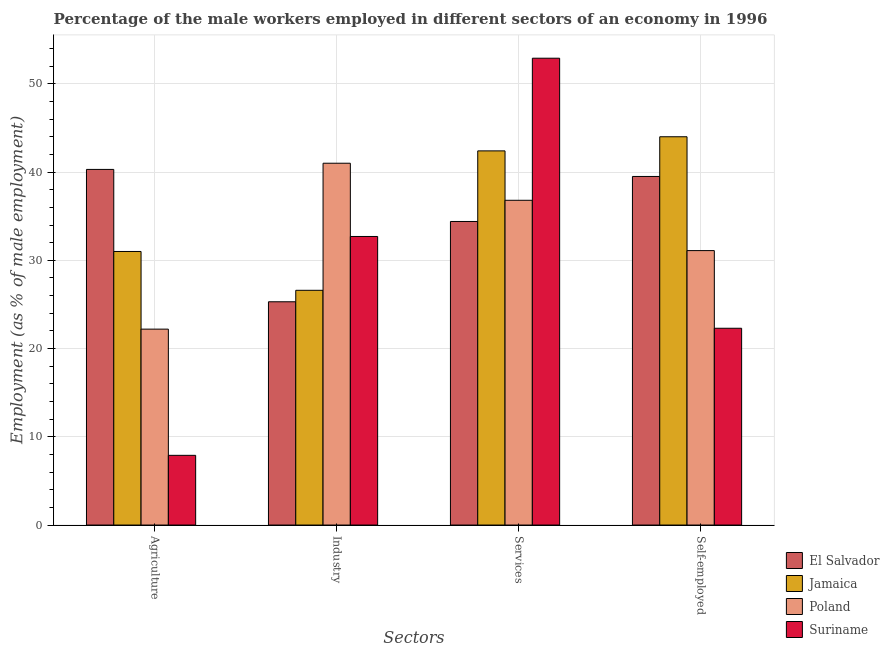How many different coloured bars are there?
Keep it short and to the point. 4. How many bars are there on the 4th tick from the right?
Offer a terse response. 4. What is the label of the 1st group of bars from the left?
Provide a short and direct response. Agriculture. What is the percentage of self employed male workers in Suriname?
Your response must be concise. 22.3. Across all countries, what is the maximum percentage of male workers in services?
Offer a very short reply. 52.9. Across all countries, what is the minimum percentage of self employed male workers?
Keep it short and to the point. 22.3. In which country was the percentage of male workers in agriculture maximum?
Offer a very short reply. El Salvador. In which country was the percentage of male workers in industry minimum?
Ensure brevity in your answer.  El Salvador. What is the total percentage of male workers in services in the graph?
Offer a terse response. 166.5. What is the difference between the percentage of male workers in agriculture in Poland and that in El Salvador?
Provide a short and direct response. -18.1. What is the difference between the percentage of male workers in industry in Suriname and the percentage of male workers in services in Poland?
Keep it short and to the point. -4.1. What is the average percentage of male workers in services per country?
Provide a succinct answer. 41.63. What is the difference between the percentage of self employed male workers and percentage of male workers in agriculture in El Salvador?
Provide a succinct answer. -0.8. In how many countries, is the percentage of male workers in services greater than 48 %?
Your answer should be compact. 1. What is the ratio of the percentage of male workers in services in Jamaica to that in El Salvador?
Offer a very short reply. 1.23. What is the difference between the highest and the second highest percentage of self employed male workers?
Your response must be concise. 4.5. What is the difference between the highest and the lowest percentage of male workers in agriculture?
Provide a short and direct response. 32.4. Is the sum of the percentage of male workers in industry in Jamaica and Suriname greater than the maximum percentage of male workers in services across all countries?
Offer a terse response. Yes. Is it the case that in every country, the sum of the percentage of male workers in agriculture and percentage of male workers in industry is greater than the sum of percentage of male workers in services and percentage of self employed male workers?
Your answer should be very brief. No. What does the 2nd bar from the left in Industry represents?
Your answer should be compact. Jamaica. What does the 4th bar from the right in Services represents?
Your answer should be compact. El Salvador. Is it the case that in every country, the sum of the percentage of male workers in agriculture and percentage of male workers in industry is greater than the percentage of male workers in services?
Offer a very short reply. No. How many bars are there?
Give a very brief answer. 16. Are all the bars in the graph horizontal?
Offer a terse response. No. How many countries are there in the graph?
Your answer should be very brief. 4. Are the values on the major ticks of Y-axis written in scientific E-notation?
Provide a succinct answer. No. Does the graph contain any zero values?
Offer a terse response. No. Does the graph contain grids?
Ensure brevity in your answer.  Yes. How many legend labels are there?
Provide a short and direct response. 4. How are the legend labels stacked?
Offer a very short reply. Vertical. What is the title of the graph?
Your answer should be very brief. Percentage of the male workers employed in different sectors of an economy in 1996. What is the label or title of the X-axis?
Keep it short and to the point. Sectors. What is the label or title of the Y-axis?
Offer a terse response. Employment (as % of male employment). What is the Employment (as % of male employment) in El Salvador in Agriculture?
Give a very brief answer. 40.3. What is the Employment (as % of male employment) of Poland in Agriculture?
Ensure brevity in your answer.  22.2. What is the Employment (as % of male employment) of Suriname in Agriculture?
Give a very brief answer. 7.9. What is the Employment (as % of male employment) in El Salvador in Industry?
Give a very brief answer. 25.3. What is the Employment (as % of male employment) of Jamaica in Industry?
Give a very brief answer. 26.6. What is the Employment (as % of male employment) in Suriname in Industry?
Give a very brief answer. 32.7. What is the Employment (as % of male employment) in El Salvador in Services?
Give a very brief answer. 34.4. What is the Employment (as % of male employment) of Jamaica in Services?
Ensure brevity in your answer.  42.4. What is the Employment (as % of male employment) of Poland in Services?
Your answer should be very brief. 36.8. What is the Employment (as % of male employment) of Suriname in Services?
Provide a short and direct response. 52.9. What is the Employment (as % of male employment) in El Salvador in Self-employed?
Your answer should be very brief. 39.5. What is the Employment (as % of male employment) of Poland in Self-employed?
Keep it short and to the point. 31.1. What is the Employment (as % of male employment) in Suriname in Self-employed?
Offer a terse response. 22.3. Across all Sectors, what is the maximum Employment (as % of male employment) in El Salvador?
Ensure brevity in your answer.  40.3. Across all Sectors, what is the maximum Employment (as % of male employment) in Poland?
Your response must be concise. 41. Across all Sectors, what is the maximum Employment (as % of male employment) in Suriname?
Keep it short and to the point. 52.9. Across all Sectors, what is the minimum Employment (as % of male employment) in El Salvador?
Provide a succinct answer. 25.3. Across all Sectors, what is the minimum Employment (as % of male employment) in Jamaica?
Offer a very short reply. 26.6. Across all Sectors, what is the minimum Employment (as % of male employment) of Poland?
Provide a short and direct response. 22.2. Across all Sectors, what is the minimum Employment (as % of male employment) of Suriname?
Provide a short and direct response. 7.9. What is the total Employment (as % of male employment) of El Salvador in the graph?
Your answer should be compact. 139.5. What is the total Employment (as % of male employment) in Jamaica in the graph?
Give a very brief answer. 144. What is the total Employment (as % of male employment) in Poland in the graph?
Your response must be concise. 131.1. What is the total Employment (as % of male employment) in Suriname in the graph?
Ensure brevity in your answer.  115.8. What is the difference between the Employment (as % of male employment) of El Salvador in Agriculture and that in Industry?
Offer a terse response. 15. What is the difference between the Employment (as % of male employment) of Poland in Agriculture and that in Industry?
Offer a terse response. -18.8. What is the difference between the Employment (as % of male employment) of Suriname in Agriculture and that in Industry?
Ensure brevity in your answer.  -24.8. What is the difference between the Employment (as % of male employment) of El Salvador in Agriculture and that in Services?
Your response must be concise. 5.9. What is the difference between the Employment (as % of male employment) of Poland in Agriculture and that in Services?
Provide a short and direct response. -14.6. What is the difference between the Employment (as % of male employment) of Suriname in Agriculture and that in Services?
Keep it short and to the point. -45. What is the difference between the Employment (as % of male employment) in Jamaica in Agriculture and that in Self-employed?
Offer a very short reply. -13. What is the difference between the Employment (as % of male employment) of Poland in Agriculture and that in Self-employed?
Offer a terse response. -8.9. What is the difference between the Employment (as % of male employment) in Suriname in Agriculture and that in Self-employed?
Your answer should be very brief. -14.4. What is the difference between the Employment (as % of male employment) in Jamaica in Industry and that in Services?
Your response must be concise. -15.8. What is the difference between the Employment (as % of male employment) of Suriname in Industry and that in Services?
Provide a succinct answer. -20.2. What is the difference between the Employment (as % of male employment) of Jamaica in Industry and that in Self-employed?
Give a very brief answer. -17.4. What is the difference between the Employment (as % of male employment) in Suriname in Industry and that in Self-employed?
Provide a short and direct response. 10.4. What is the difference between the Employment (as % of male employment) in El Salvador in Services and that in Self-employed?
Give a very brief answer. -5.1. What is the difference between the Employment (as % of male employment) of Suriname in Services and that in Self-employed?
Provide a short and direct response. 30.6. What is the difference between the Employment (as % of male employment) of El Salvador in Agriculture and the Employment (as % of male employment) of Poland in Services?
Make the answer very short. 3.5. What is the difference between the Employment (as % of male employment) in Jamaica in Agriculture and the Employment (as % of male employment) in Poland in Services?
Make the answer very short. -5.8. What is the difference between the Employment (as % of male employment) in Jamaica in Agriculture and the Employment (as % of male employment) in Suriname in Services?
Your response must be concise. -21.9. What is the difference between the Employment (as % of male employment) of Poland in Agriculture and the Employment (as % of male employment) of Suriname in Services?
Your answer should be very brief. -30.7. What is the difference between the Employment (as % of male employment) of Poland in Agriculture and the Employment (as % of male employment) of Suriname in Self-employed?
Your answer should be very brief. -0.1. What is the difference between the Employment (as % of male employment) of El Salvador in Industry and the Employment (as % of male employment) of Jamaica in Services?
Offer a terse response. -17.1. What is the difference between the Employment (as % of male employment) of El Salvador in Industry and the Employment (as % of male employment) of Suriname in Services?
Your answer should be compact. -27.6. What is the difference between the Employment (as % of male employment) in Jamaica in Industry and the Employment (as % of male employment) in Suriname in Services?
Provide a short and direct response. -26.3. What is the difference between the Employment (as % of male employment) of Poland in Industry and the Employment (as % of male employment) of Suriname in Services?
Your answer should be very brief. -11.9. What is the difference between the Employment (as % of male employment) in El Salvador in Industry and the Employment (as % of male employment) in Jamaica in Self-employed?
Keep it short and to the point. -18.7. What is the difference between the Employment (as % of male employment) of El Salvador in Industry and the Employment (as % of male employment) of Suriname in Self-employed?
Your answer should be compact. 3. What is the difference between the Employment (as % of male employment) in Jamaica in Industry and the Employment (as % of male employment) in Suriname in Self-employed?
Ensure brevity in your answer.  4.3. What is the difference between the Employment (as % of male employment) of El Salvador in Services and the Employment (as % of male employment) of Jamaica in Self-employed?
Make the answer very short. -9.6. What is the difference between the Employment (as % of male employment) in El Salvador in Services and the Employment (as % of male employment) in Poland in Self-employed?
Provide a short and direct response. 3.3. What is the difference between the Employment (as % of male employment) in Jamaica in Services and the Employment (as % of male employment) in Suriname in Self-employed?
Your answer should be very brief. 20.1. What is the average Employment (as % of male employment) in El Salvador per Sectors?
Your answer should be very brief. 34.88. What is the average Employment (as % of male employment) of Jamaica per Sectors?
Provide a short and direct response. 36. What is the average Employment (as % of male employment) in Poland per Sectors?
Give a very brief answer. 32.77. What is the average Employment (as % of male employment) in Suriname per Sectors?
Offer a very short reply. 28.95. What is the difference between the Employment (as % of male employment) in El Salvador and Employment (as % of male employment) in Poland in Agriculture?
Provide a short and direct response. 18.1. What is the difference between the Employment (as % of male employment) in El Salvador and Employment (as % of male employment) in Suriname in Agriculture?
Make the answer very short. 32.4. What is the difference between the Employment (as % of male employment) in Jamaica and Employment (as % of male employment) in Poland in Agriculture?
Your answer should be compact. 8.8. What is the difference between the Employment (as % of male employment) in Jamaica and Employment (as % of male employment) in Suriname in Agriculture?
Your answer should be compact. 23.1. What is the difference between the Employment (as % of male employment) of Poland and Employment (as % of male employment) of Suriname in Agriculture?
Give a very brief answer. 14.3. What is the difference between the Employment (as % of male employment) in El Salvador and Employment (as % of male employment) in Jamaica in Industry?
Offer a very short reply. -1.3. What is the difference between the Employment (as % of male employment) of El Salvador and Employment (as % of male employment) of Poland in Industry?
Your answer should be very brief. -15.7. What is the difference between the Employment (as % of male employment) of El Salvador and Employment (as % of male employment) of Suriname in Industry?
Your response must be concise. -7.4. What is the difference between the Employment (as % of male employment) of Jamaica and Employment (as % of male employment) of Poland in Industry?
Provide a short and direct response. -14.4. What is the difference between the Employment (as % of male employment) in Jamaica and Employment (as % of male employment) in Suriname in Industry?
Make the answer very short. -6.1. What is the difference between the Employment (as % of male employment) of El Salvador and Employment (as % of male employment) of Jamaica in Services?
Make the answer very short. -8. What is the difference between the Employment (as % of male employment) of El Salvador and Employment (as % of male employment) of Poland in Services?
Your response must be concise. -2.4. What is the difference between the Employment (as % of male employment) of El Salvador and Employment (as % of male employment) of Suriname in Services?
Your answer should be compact. -18.5. What is the difference between the Employment (as % of male employment) in Jamaica and Employment (as % of male employment) in Poland in Services?
Ensure brevity in your answer.  5.6. What is the difference between the Employment (as % of male employment) of Jamaica and Employment (as % of male employment) of Suriname in Services?
Offer a very short reply. -10.5. What is the difference between the Employment (as % of male employment) of Poland and Employment (as % of male employment) of Suriname in Services?
Provide a succinct answer. -16.1. What is the difference between the Employment (as % of male employment) of El Salvador and Employment (as % of male employment) of Jamaica in Self-employed?
Your answer should be very brief. -4.5. What is the difference between the Employment (as % of male employment) in Jamaica and Employment (as % of male employment) in Poland in Self-employed?
Keep it short and to the point. 12.9. What is the difference between the Employment (as % of male employment) of Jamaica and Employment (as % of male employment) of Suriname in Self-employed?
Offer a terse response. 21.7. What is the ratio of the Employment (as % of male employment) of El Salvador in Agriculture to that in Industry?
Ensure brevity in your answer.  1.59. What is the ratio of the Employment (as % of male employment) of Jamaica in Agriculture to that in Industry?
Your answer should be compact. 1.17. What is the ratio of the Employment (as % of male employment) of Poland in Agriculture to that in Industry?
Offer a terse response. 0.54. What is the ratio of the Employment (as % of male employment) in Suriname in Agriculture to that in Industry?
Your response must be concise. 0.24. What is the ratio of the Employment (as % of male employment) of El Salvador in Agriculture to that in Services?
Keep it short and to the point. 1.17. What is the ratio of the Employment (as % of male employment) in Jamaica in Agriculture to that in Services?
Your response must be concise. 0.73. What is the ratio of the Employment (as % of male employment) in Poland in Agriculture to that in Services?
Provide a succinct answer. 0.6. What is the ratio of the Employment (as % of male employment) of Suriname in Agriculture to that in Services?
Offer a very short reply. 0.15. What is the ratio of the Employment (as % of male employment) of El Salvador in Agriculture to that in Self-employed?
Offer a terse response. 1.02. What is the ratio of the Employment (as % of male employment) of Jamaica in Agriculture to that in Self-employed?
Your answer should be very brief. 0.7. What is the ratio of the Employment (as % of male employment) in Poland in Agriculture to that in Self-employed?
Provide a short and direct response. 0.71. What is the ratio of the Employment (as % of male employment) in Suriname in Agriculture to that in Self-employed?
Provide a succinct answer. 0.35. What is the ratio of the Employment (as % of male employment) in El Salvador in Industry to that in Services?
Make the answer very short. 0.74. What is the ratio of the Employment (as % of male employment) in Jamaica in Industry to that in Services?
Make the answer very short. 0.63. What is the ratio of the Employment (as % of male employment) of Poland in Industry to that in Services?
Offer a terse response. 1.11. What is the ratio of the Employment (as % of male employment) of Suriname in Industry to that in Services?
Ensure brevity in your answer.  0.62. What is the ratio of the Employment (as % of male employment) in El Salvador in Industry to that in Self-employed?
Offer a very short reply. 0.64. What is the ratio of the Employment (as % of male employment) in Jamaica in Industry to that in Self-employed?
Your response must be concise. 0.6. What is the ratio of the Employment (as % of male employment) in Poland in Industry to that in Self-employed?
Offer a terse response. 1.32. What is the ratio of the Employment (as % of male employment) of Suriname in Industry to that in Self-employed?
Offer a terse response. 1.47. What is the ratio of the Employment (as % of male employment) in El Salvador in Services to that in Self-employed?
Provide a succinct answer. 0.87. What is the ratio of the Employment (as % of male employment) of Jamaica in Services to that in Self-employed?
Provide a short and direct response. 0.96. What is the ratio of the Employment (as % of male employment) in Poland in Services to that in Self-employed?
Provide a short and direct response. 1.18. What is the ratio of the Employment (as % of male employment) in Suriname in Services to that in Self-employed?
Keep it short and to the point. 2.37. What is the difference between the highest and the second highest Employment (as % of male employment) of Suriname?
Make the answer very short. 20.2. What is the difference between the highest and the lowest Employment (as % of male employment) of Jamaica?
Offer a very short reply. 17.4. What is the difference between the highest and the lowest Employment (as % of male employment) in Suriname?
Provide a short and direct response. 45. 